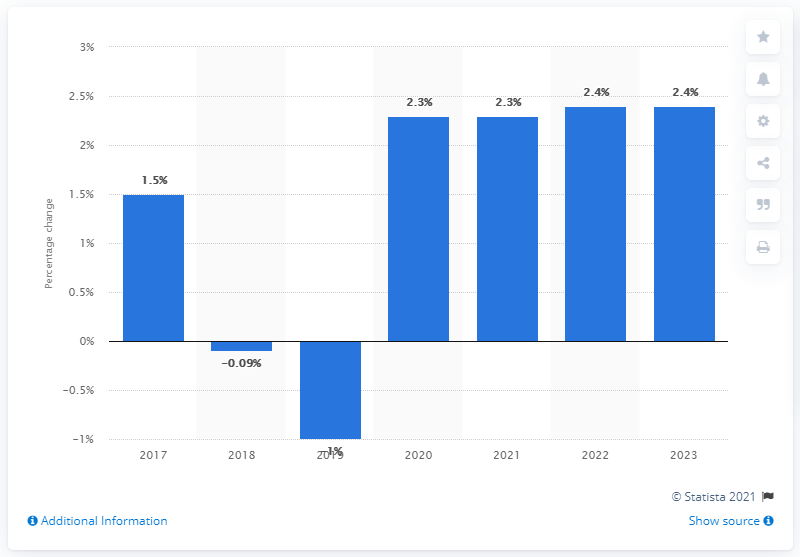Give some essential details in this illustration. According to forecasts, approximately 2.3% of business investment is expected to remain stable in both 2020 and 2021. 